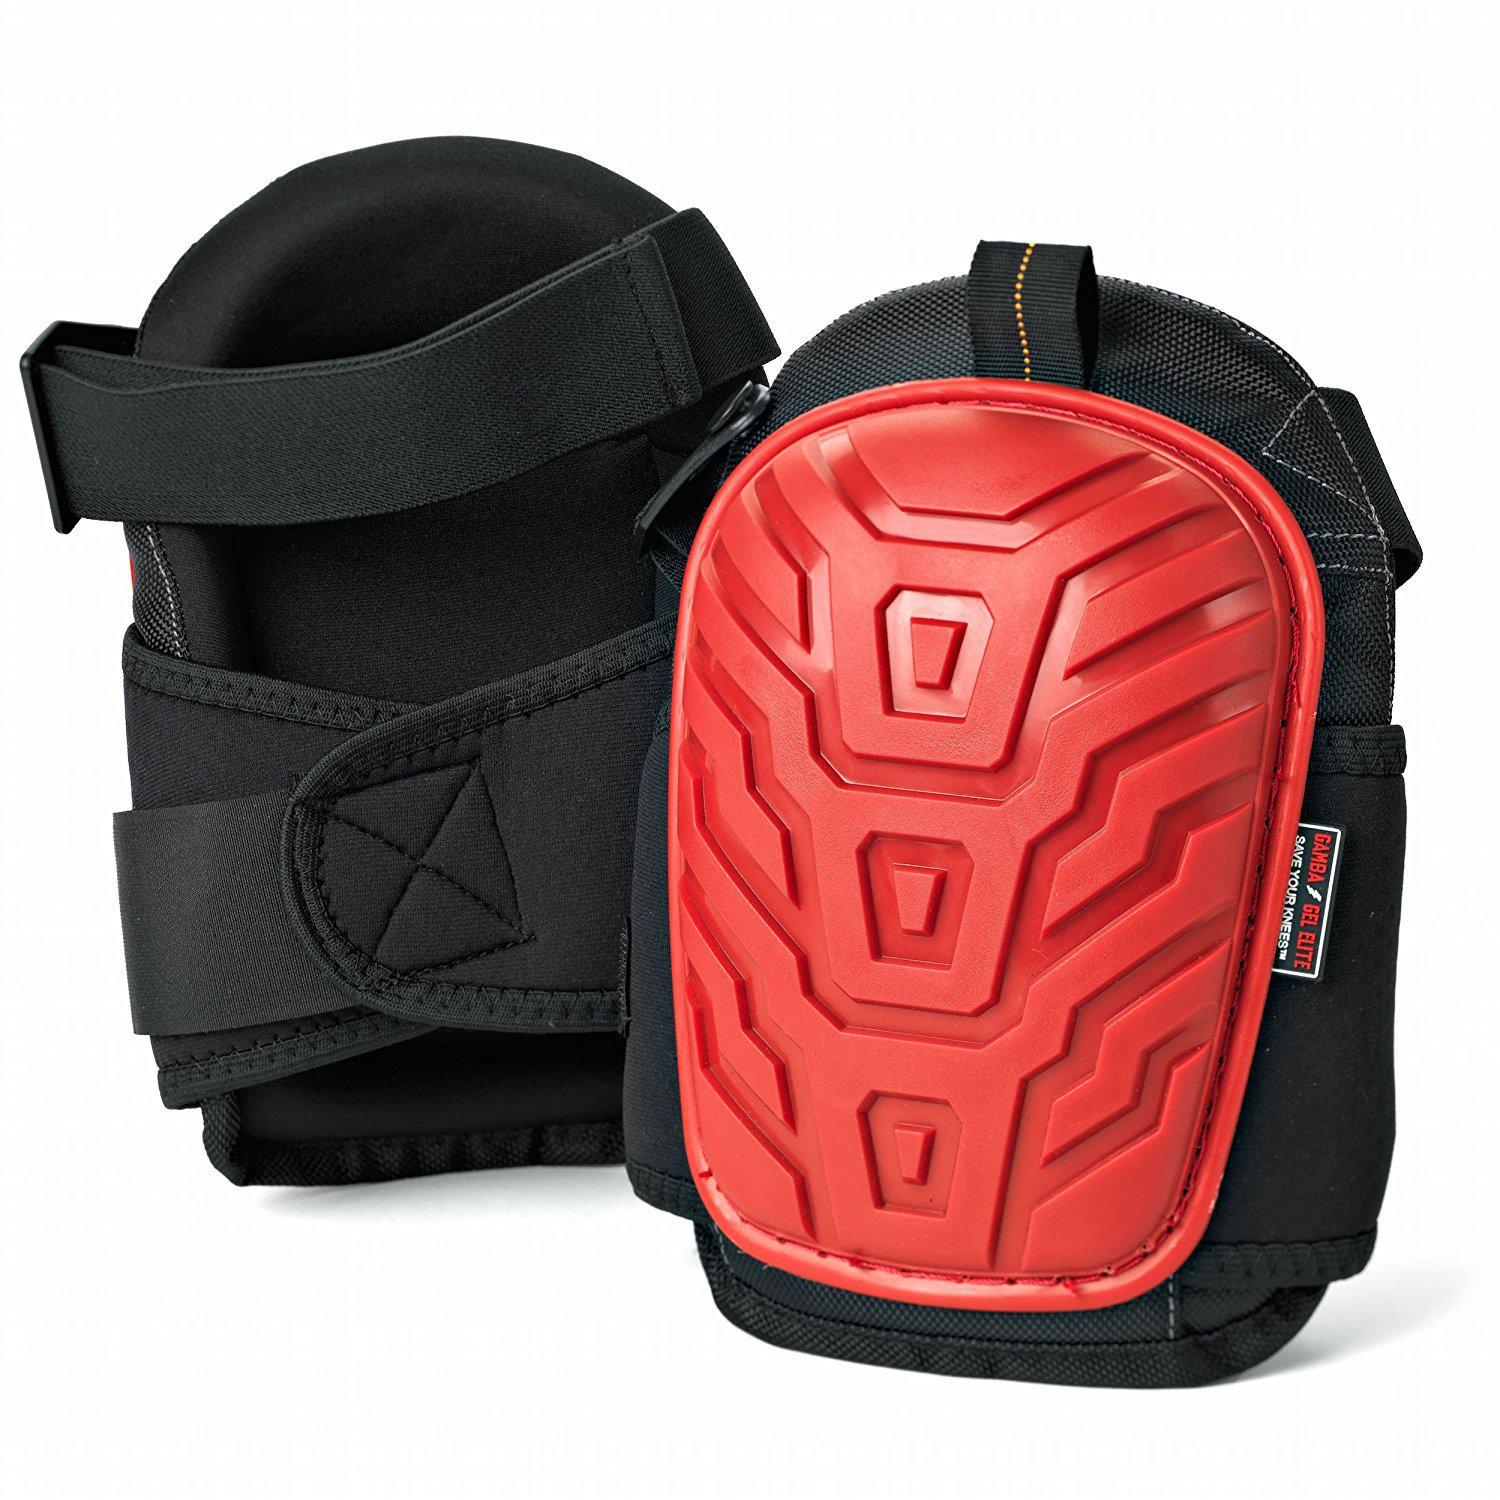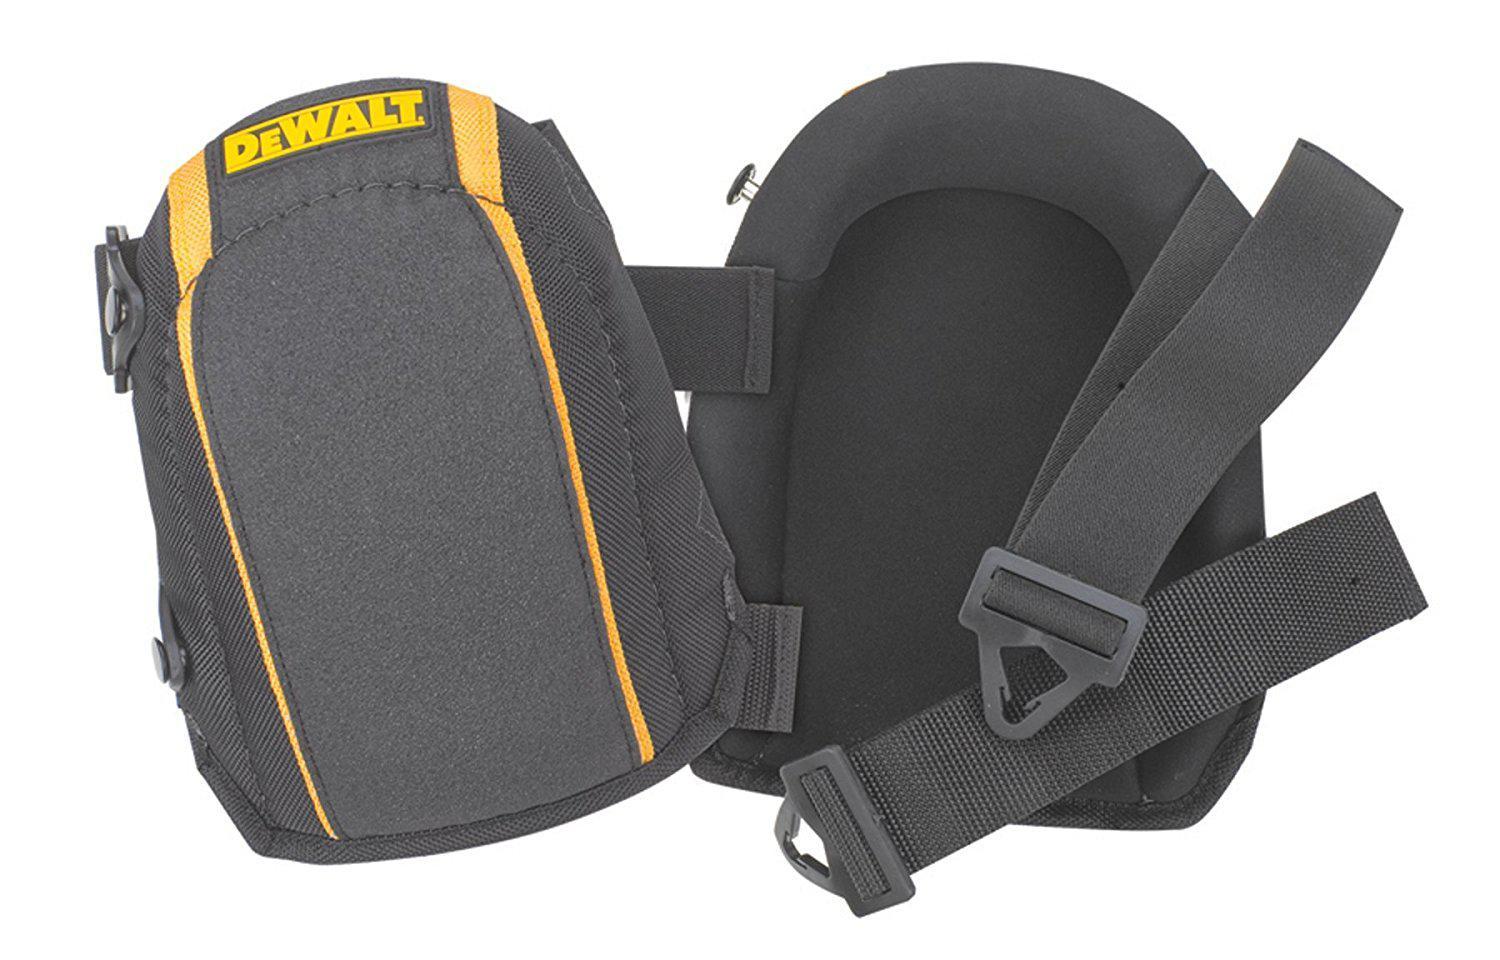The first image is the image on the left, the second image is the image on the right. Analyze the images presented: Is the assertion "At least one of the sets of knee pads is only yellow and grey." valid? Answer yes or no. Yes. The first image is the image on the left, the second image is the image on the right. Given the left and right images, does the statement "An image shows a pair of black knee pads with yellow trim on the front." hold true? Answer yes or no. Yes. 